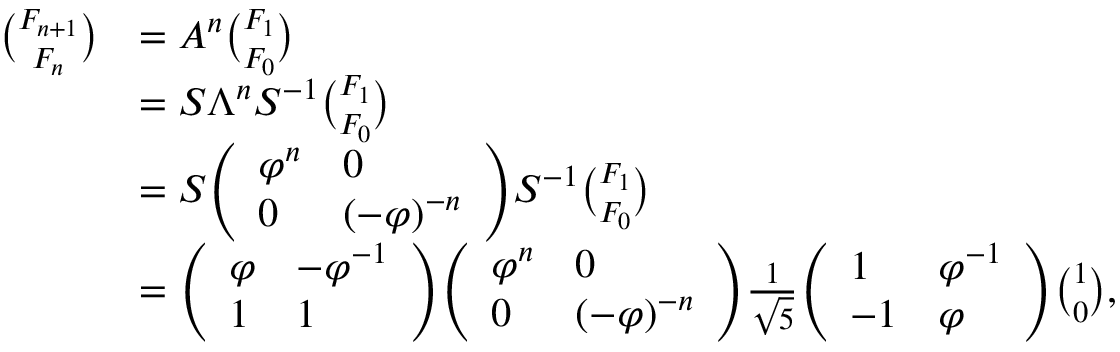<formula> <loc_0><loc_0><loc_500><loc_500>{ \begin{array} { r l } { { \binom { F _ { n + 1 } } { F _ { n } } } } & { = A ^ { n } { \binom { F _ { 1 } } { F _ { 0 } } } } \\ & { = S \Lambda ^ { n } S ^ { - 1 } { \binom { F _ { 1 } } { F _ { 0 } } } } \\ & { = S { \left ( \begin{array} { l l } { \varphi ^ { n } } & { 0 } \\ { 0 } & { ( - \varphi ) ^ { - n } } \end{array} \right ) } S ^ { - 1 } { \binom { F _ { 1 } } { F _ { 0 } } } } \\ & { = { \left ( \begin{array} { l l } { \varphi } & { - \varphi ^ { - 1 } } \\ { 1 } & { 1 } \end{array} \right ) } { \left ( \begin{array} { l l } { \varphi ^ { n } } & { 0 } \\ { 0 } & { ( - \varphi ) ^ { - n } } \end{array} \right ) } { \frac { 1 } { \sqrt { 5 } } } { \left ( \begin{array} { l l } { 1 } & { \varphi ^ { - 1 } } \\ { - 1 } & { \varphi } \end{array} \right ) } { \binom { 1 } { 0 } } , } \end{array} }</formula> 